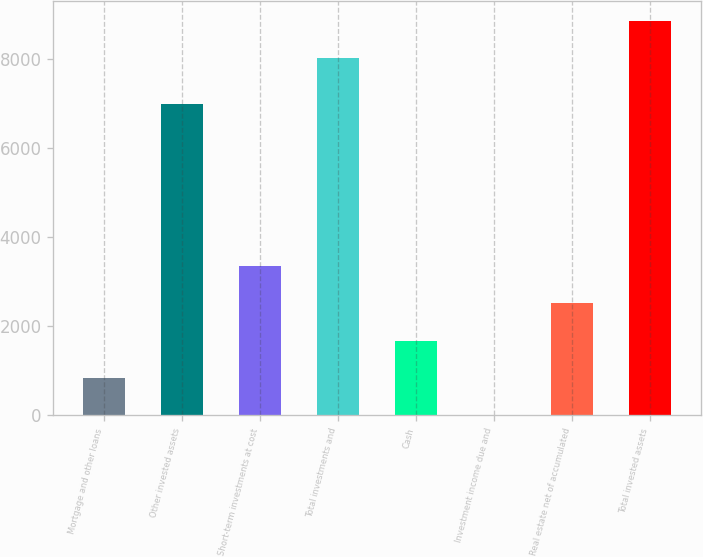<chart> <loc_0><loc_0><loc_500><loc_500><bar_chart><fcel>Mortgage and other loans<fcel>Other invested assets<fcel>Short-term investments at cost<fcel>Total investments and<fcel>Cash<fcel>Investment income due and<fcel>Real estate net of accumulated<fcel>Total invested assets<nl><fcel>839.6<fcel>6989<fcel>3352.4<fcel>8020<fcel>1677.2<fcel>2<fcel>2514.8<fcel>8857.6<nl></chart> 